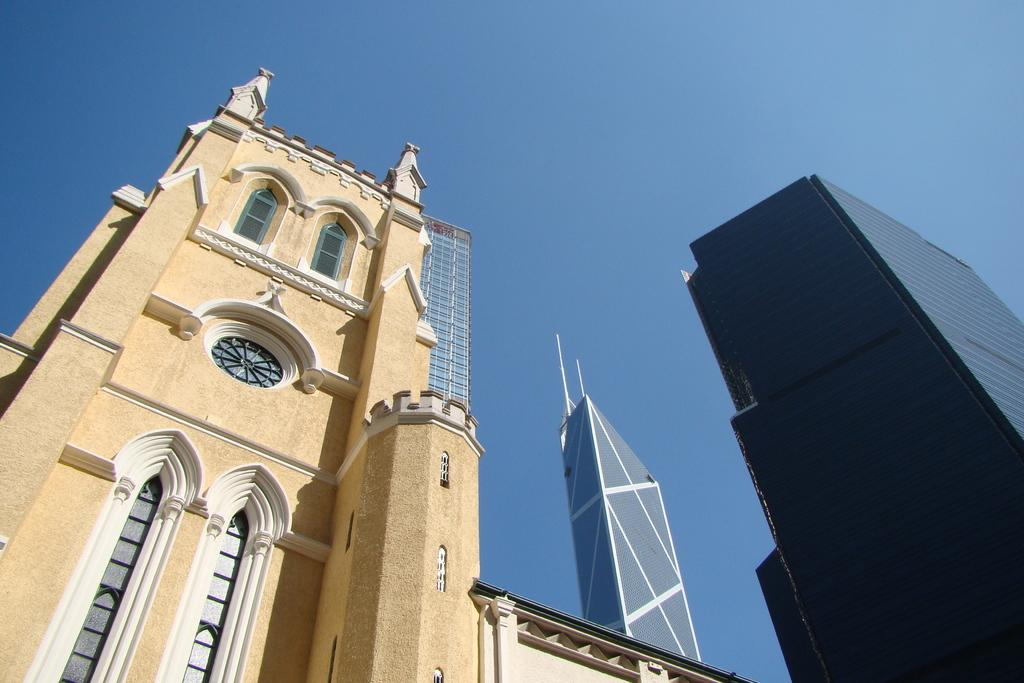What type of structures can be seen in the image? There are buildings in the image. What feature is visible on the buildings? Windows are visible in the image. What type of security or architectural element is present in the image? Iron grills are present in the image. What can be seen in the background of the image? The sky is visible in the background of the image. What type of flowers can be smelled in the image? There are no flowers present in the image, so there is no scent to be smelled. 